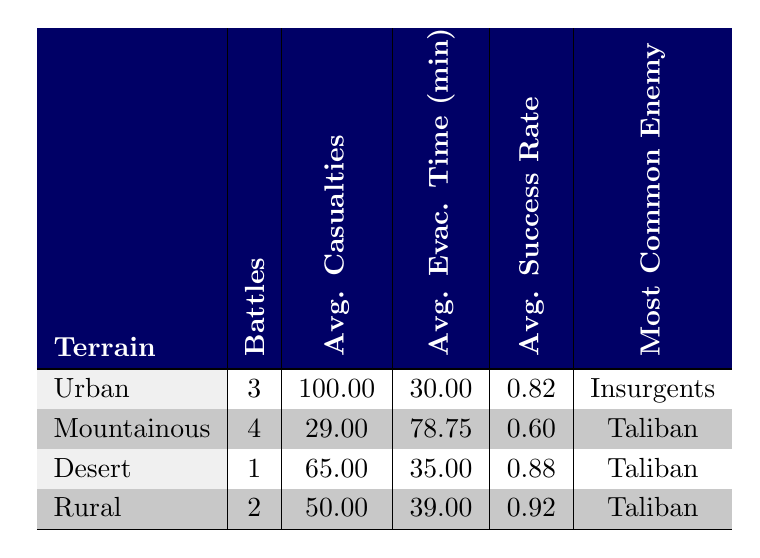What is the average number of casualties in Urban terrain battles? There are three entries for battles in Urban terrain: 95 (Fallujah), 110 (Ramadi), and 95 (Second Fallujah). To find the average, I sum these values: 95 + 110 + 95 = 300. Then I divide by the number of battles, which is 3. So, 300/3 = 100.
Answer: 100 What is the most common enemy encountered in Rural terrain? The battles listed under Rural terrain are Operation Medusa and Operation Moshtarak. Both battles faced the Taliban, indicating that the Taliban is the most common enemy in this terrain.
Answer: Taliban True or False: The average evacuation time for Mountainous terrain is less than 80 minutes. The average evacuation time for Mountainous terrain is 78.75 minutes. Since 78.75 is indeed less than 80, the statement is true.
Answer: True What is the difference between the average success rates of Urban and Mountainous terrains? The average success rate for Urban terrain is 0.82, and for Mountainous terrain, it is 0.60. To find the difference, I subtract the two values: 0.82 - 0.60 = 0.22. Therefore, the difference in average success rate is 0.22.
Answer: 0.22 How many battles occurred in Mountainous terrain? There are four recorded battles in Mountainous terrain: Operation Anaconda, Battle of Wanat, and two others. The table indicates that the number of battles in Mountainous terrain is 4.
Answer: 4 What is the average evacuation time for battles against Taliban forces? The battles against the Taliban are the Battle of Marjah, Operation Medusa, Operation Moshtarak, Battle of Wanat, and Battle of Kamdesh. We calculate the average evacuation time by summing the evacuation times (35 + 40 + 38 + 60 + 90 = 263) and then dividing by the number of battles (5), giving us 263/5 = 52.6 minutes.
Answer: 52.6 Is the average casualty number for battles against Insurgents higher than 90? There are two battles against Insurgents: Battle of Fallujah and Second Battle of Fallujah, with casualties of 95 each. The average is (95 + 95) / 2 = 95, which is not higher than 90. Thus, the statement is false.
Answer: False Which terrain has the highest average success rate? Examining the success rates: Urban (0.82), Mountainous (0.60), Desert (0.88), and Rural (0.92). Clearly, Rural terrain has the highest success rate with 0.92.
Answer: Rural 